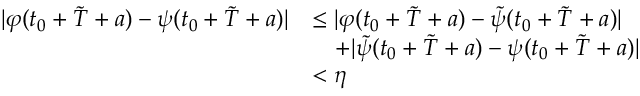Convert formula to latex. <formula><loc_0><loc_0><loc_500><loc_500>\begin{array} { r l } { | \varphi ( t _ { 0 } + \tilde { T } + a ) - \psi ( t _ { 0 } + \tilde { T } + a ) | } & { \leq | \varphi ( t _ { 0 } + \tilde { T } + a ) - \tilde { \psi } ( t _ { 0 } + \tilde { T } + a ) | } \\ & { \quad + | \tilde { \psi } ( t _ { 0 } + \tilde { T } + a ) - \psi ( t _ { 0 } + \tilde { T } + a ) | } \\ & { < \eta } \end{array}</formula> 